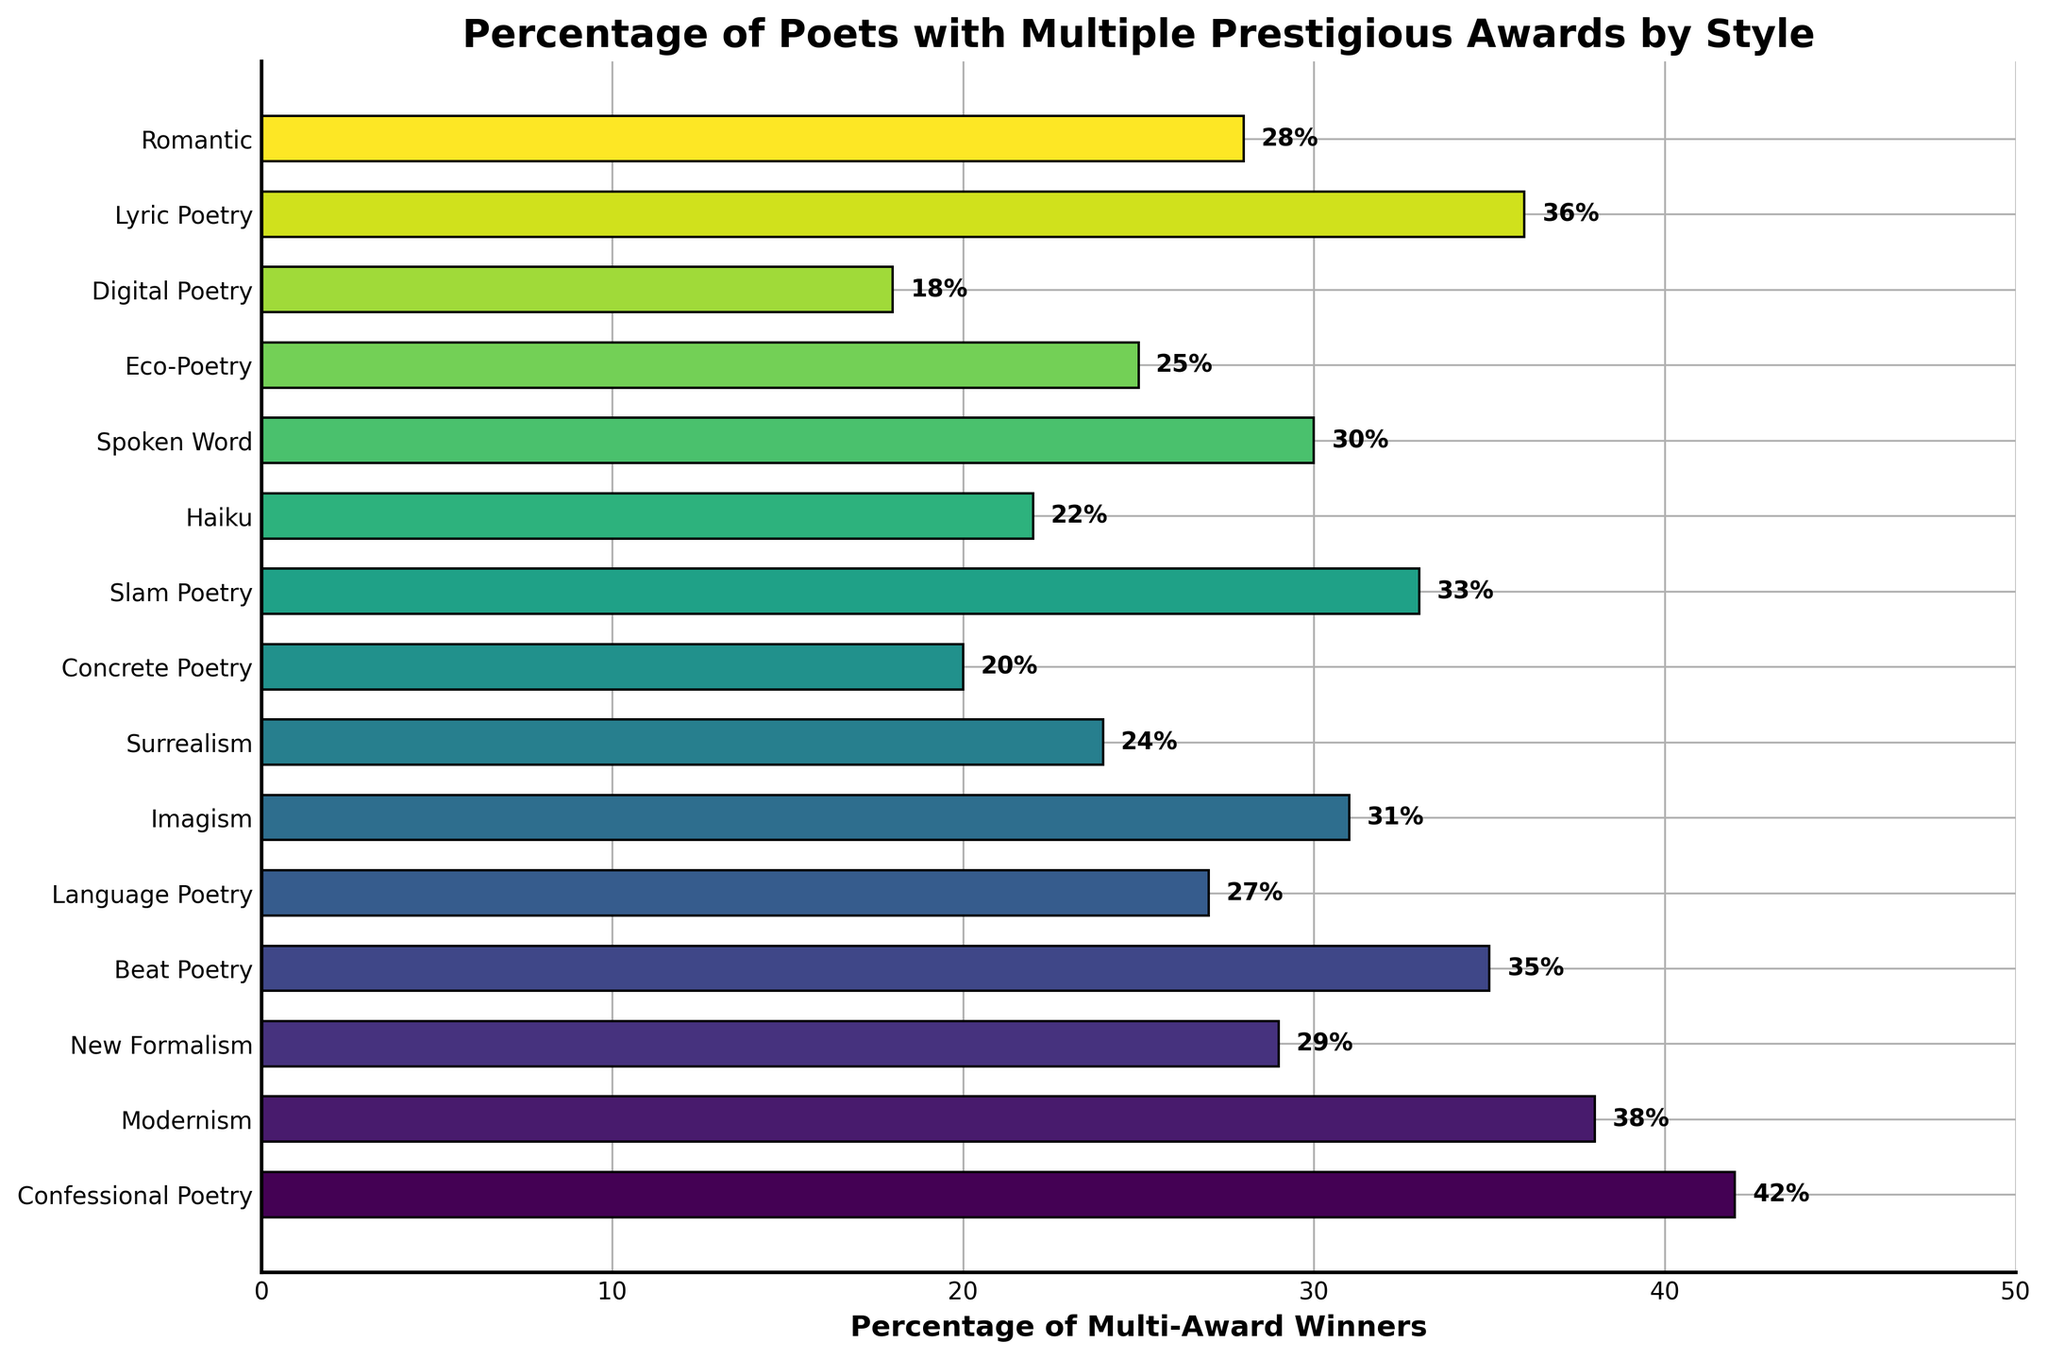Which style or movement has the highest percentage of multi-award-winning poets? The bar chart shows different styles or movements and their percentages of poets who won multiple prestigious awards. The bar with the highest percentage represents the style with the highest percentage.
Answer: Confessional Poetry Which style has the lowest percentage of multi-award-winning poets? To find the lowest, we look for the shortest bar on the chart. This bar represents the style with the smallest percentage.
Answer: Digital Poetry Are there more multi-award-winning poets in Beat Poetry or Imagism? By comparing the lengths of the bars for Beat Poetry and Imagism, we can see which is longer.
Answer: Beat Poetry What is the combined percentage of multi-award-winning poets in Modernism and Romantic styles? Adding the percentages for Modernism (38%) and Romantic (28%): 38 + 28 = 66.
Answer: 66 Is the percentage of multi-award winners in Lyric Poetry higher than in Spoken Word? We compare the bar lengths for Lyric Poetry and Spoken Word. Lyric Poetry has 36%, whereas Spoken Word has 30%.
Answer: Yes Which styles or movements have a percentage of multi-award-winning poets equal to or greater than 30%? By identifying the bars that are at least as long as the 30% mark, we find: Confessional Poetry, Modernism, Beat Poetry, Slam Poetry, Lyric Poetry, Spoken Word, and New Formalism.
Answer: Confessional Poetry, Modernism, Beat Poetry, Slam Poetry, Lyric Poetry, Spoken Word, New Formalism What is the difference in the percentage of multi-award-winning poets between Eco-Poetry and Concrete Poetry? Subtract the percentage for Concrete Poetry (20%) from that of Eco-Poetry (25%): 25 - 20 = 5.
Answer: 5 Is the percentage of multi-award winners higher in Confessional Poetry than in Modernism? The bar for Confessional Poetry reaches 42%, whereas Modernism reaches 38%.
Answer: Yes Which three styles or movements have the closest percentages of multi-award-winning poets, and what are these percentages? Looking at the chart, Beat Poetry (35%), Lyric Poetry (36%), and Modernism (38%) are close in percentage.
Answer: Beat Poetry: 35%, Lyric Poetry: 36%, Modernism: 38% What is the average percentage of multi-award-winning poets across all the styles or movements? Add up all the percentages and divide by the number of styles. (42 + 38 + 29 + 35 + 27 + 31 + 24 + 20 + 33 + 22 + 30 + 25 + 18 + 36 + 28) / 15 = 418 / 15 ≈ 27.87
Answer: Approximately 27.87 